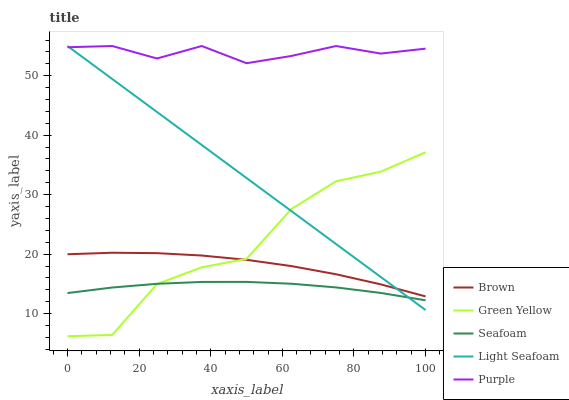Does Seafoam have the minimum area under the curve?
Answer yes or no. Yes. Does Purple have the maximum area under the curve?
Answer yes or no. Yes. Does Brown have the minimum area under the curve?
Answer yes or no. No. Does Brown have the maximum area under the curve?
Answer yes or no. No. Is Light Seafoam the smoothest?
Answer yes or no. Yes. Is Green Yellow the roughest?
Answer yes or no. Yes. Is Brown the smoothest?
Answer yes or no. No. Is Brown the roughest?
Answer yes or no. No. Does Green Yellow have the lowest value?
Answer yes or no. Yes. Does Brown have the lowest value?
Answer yes or no. No. Does Light Seafoam have the highest value?
Answer yes or no. Yes. Does Brown have the highest value?
Answer yes or no. No. Is Brown less than Purple?
Answer yes or no. Yes. Is Purple greater than Seafoam?
Answer yes or no. Yes. Does Brown intersect Light Seafoam?
Answer yes or no. Yes. Is Brown less than Light Seafoam?
Answer yes or no. No. Is Brown greater than Light Seafoam?
Answer yes or no. No. Does Brown intersect Purple?
Answer yes or no. No. 